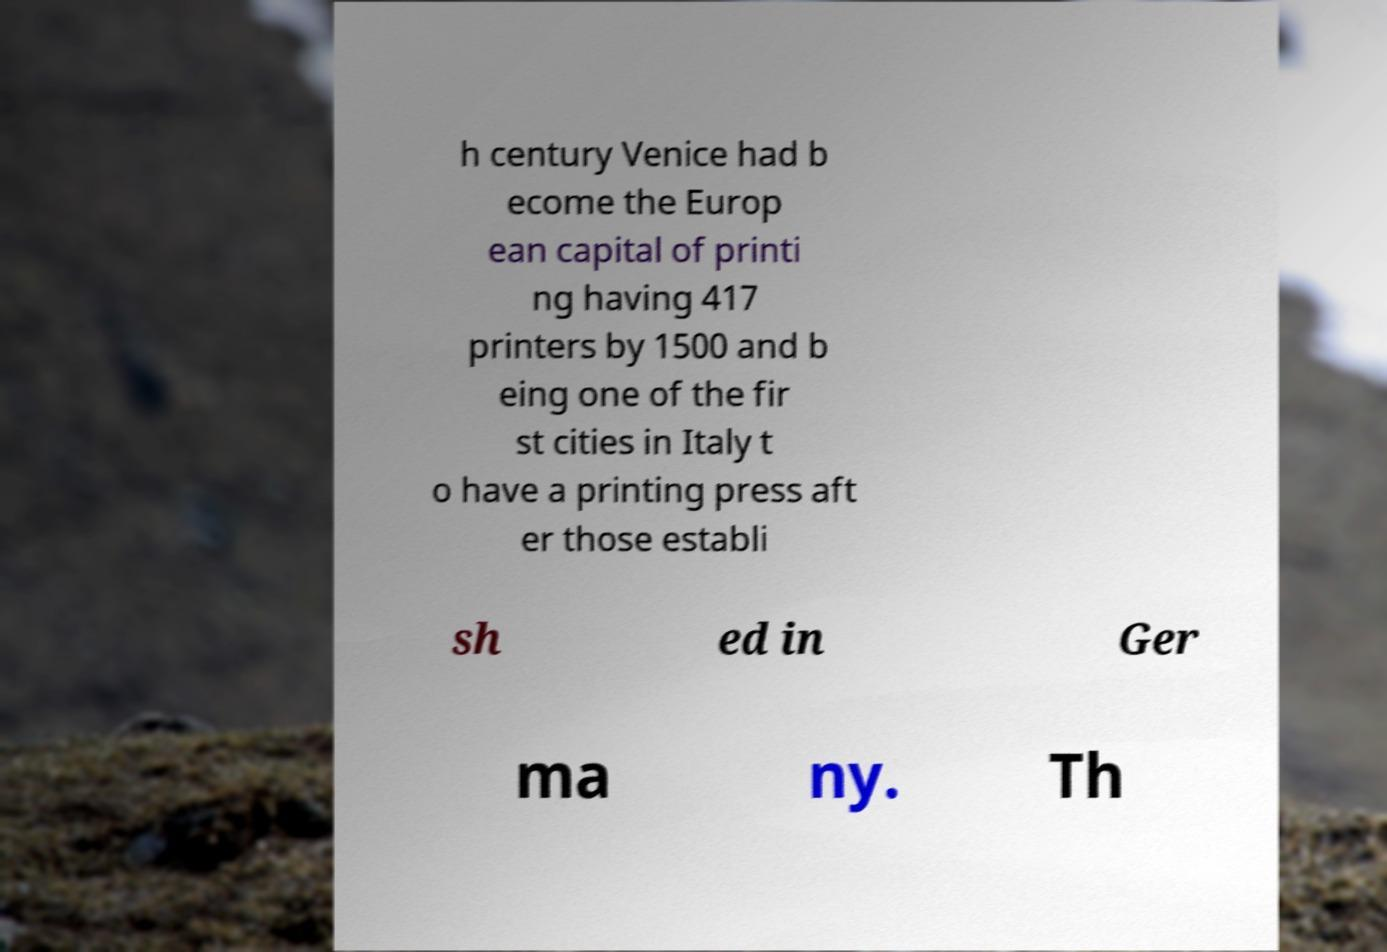What messages or text are displayed in this image? I need them in a readable, typed format. h century Venice had b ecome the Europ ean capital of printi ng having 417 printers by 1500 and b eing one of the fir st cities in Italy t o have a printing press aft er those establi sh ed in Ger ma ny. Th 